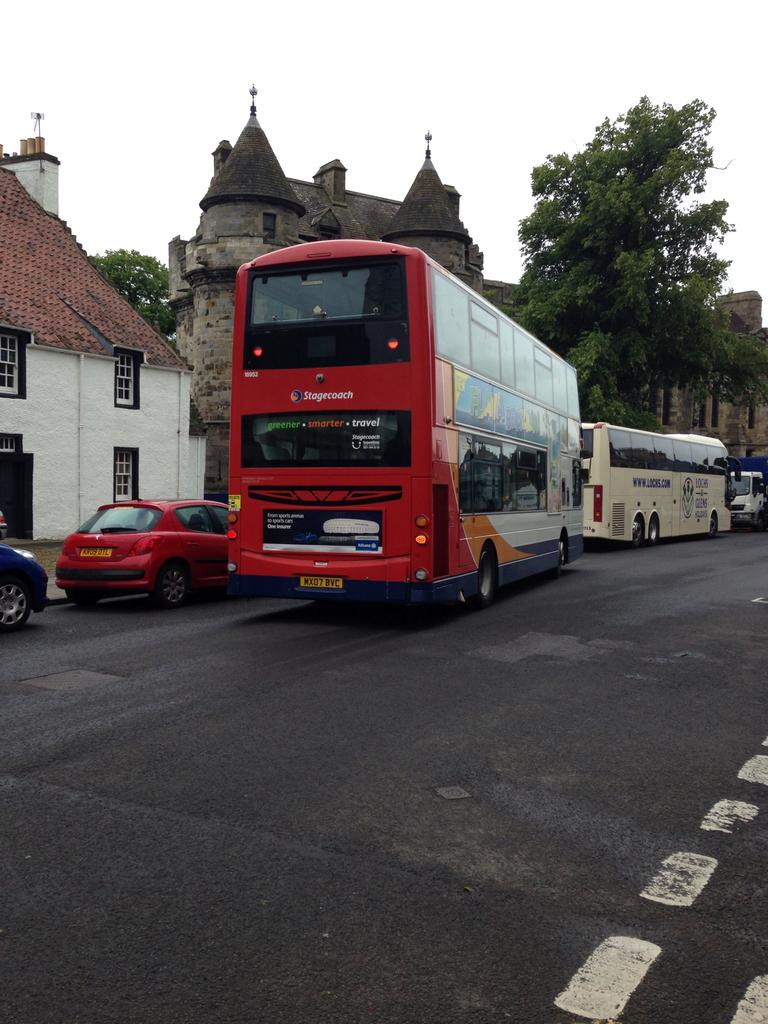<image>
Summarize the visual content of the image. A red doubledecker bus from the company Stagecoach. 